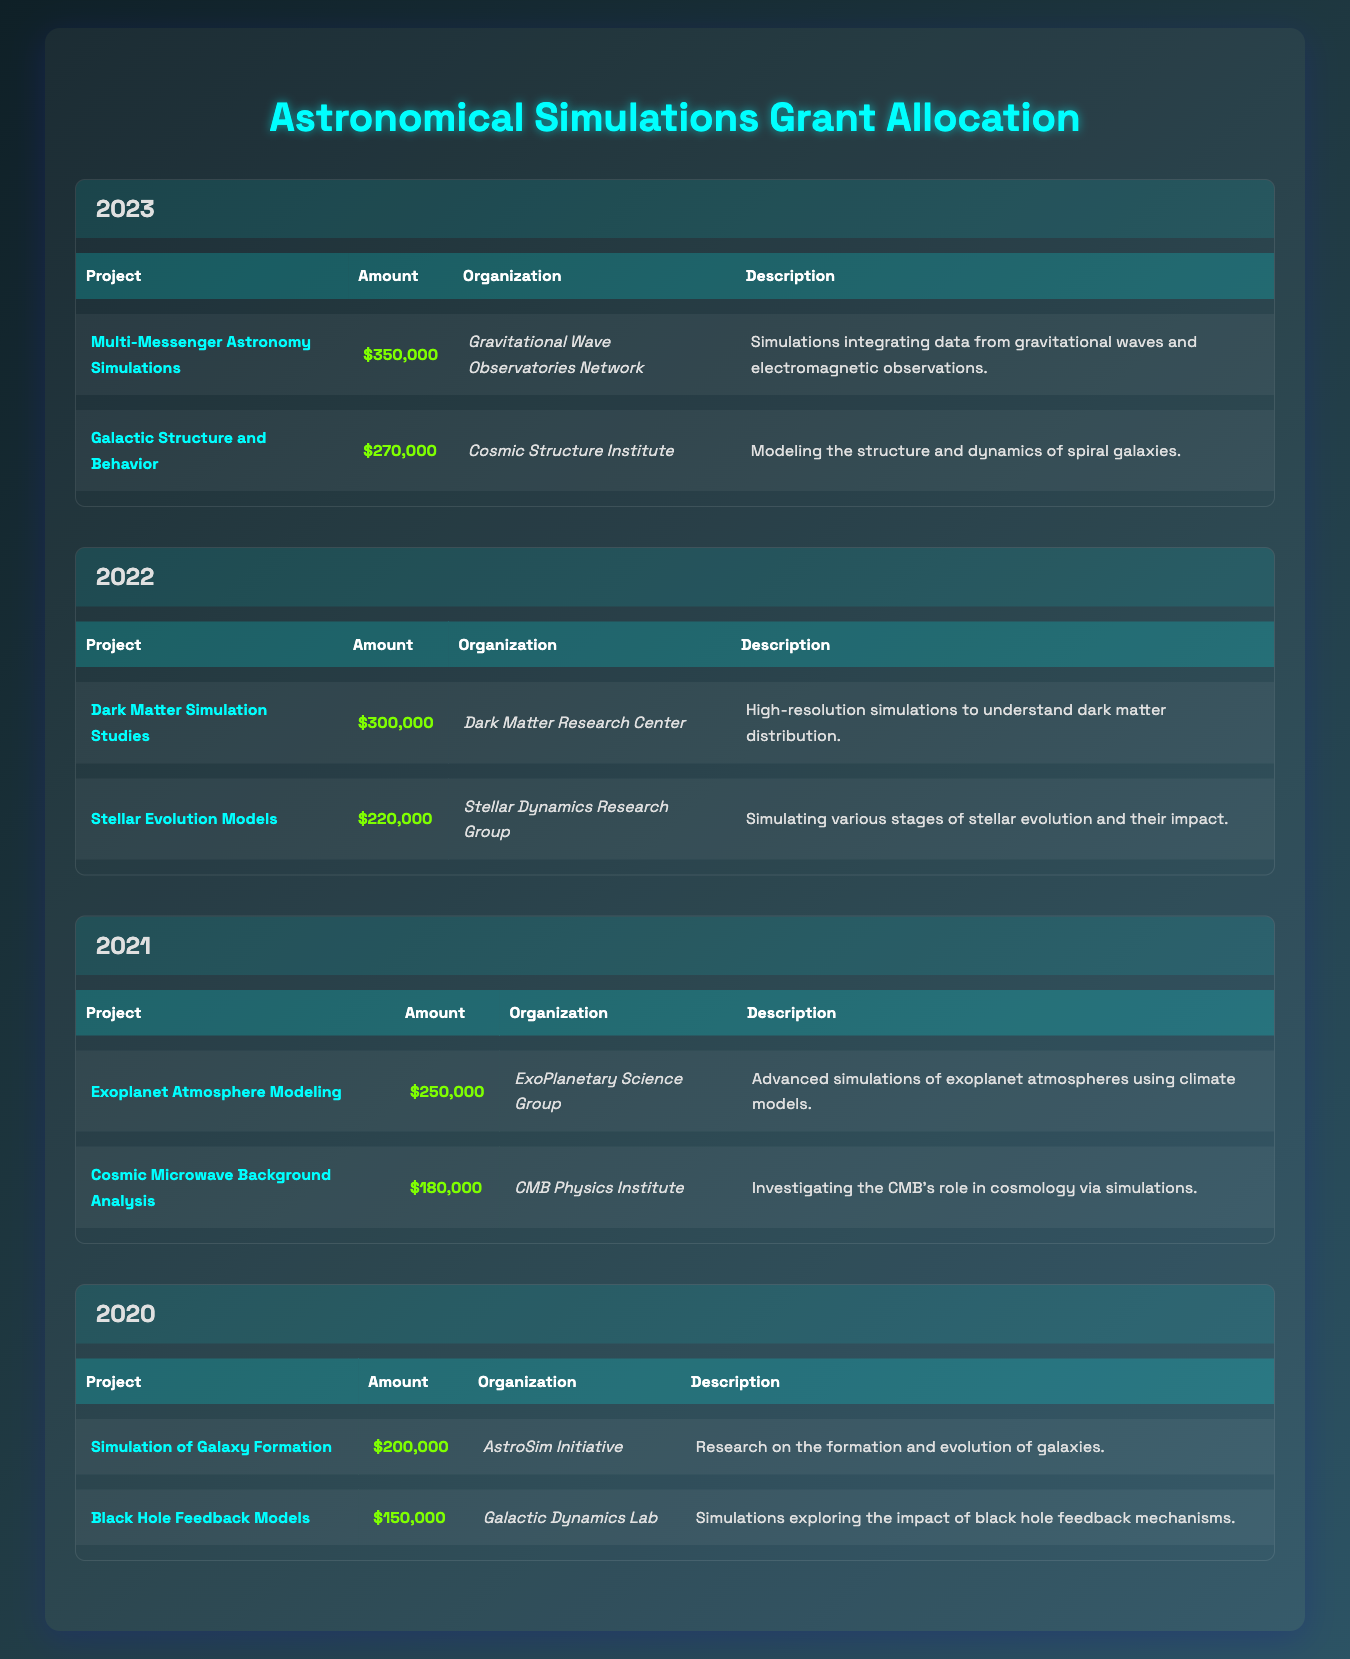What is the total grant amount allocated in 2022? In 2022, there are two projects listed with their amounts: Dark Matter Simulation Studies ($300,000) and Stellar Evolution Models ($220,000). Adding these amounts gives us $300,000 + $220,000 = $520,000.
Answer: $520,000 Which organization received the highest grant in 2023? In 2023, there are two projects: Multi-Messenger Astronomy Simulations ($350,000) and Galactic Structure and Behavior ($270,000). The organization that received the highest grant is for Multi-Messenger Astronomy Simulations, which is the Gravitational Wave Observatories Network.
Answer: Gravitational Wave Observatories Network Did the grant amount for Exoplanet Atmosphere Modeling exceed $200,000? The amount allocated for Exoplanet Atmosphere Modeling in 2021 is $250,000. Since $250,000 is greater than $200,000, the statement is true.
Answer: Yes What is the combined grant amount for all projects in 2021? In 2021, there are two projects with amounts: Exoplanet Atmosphere Modeling ($250,000) and Cosmic Microwave Background Analysis ($180,000). The combined grant amount is calculated as $250,000 + $180,000 = $430,000.
Answer: $430,000 Is there any project related to black holes in the data? The data includes a project titled Black Hole Feedback Models in 2020, which distinctly identifies its focus on black hole mechanisms. Therefore, the answer is yes, there is a project about black holes.
Answer: Yes What was the total grant amount allocated across all years from 2020 to 2023? The total amounts by year are: 2020 ($200,000 + $150,000 = $350,000), 2021 ($250,000 + $180,000 = $430,000), 2022 ($300,000 + $220,000 = $520,000), and 2023 ($350,000 + $270,000 = $620,000). Adding these totals gives $350,000 + $430,000 + $520,000 + $620,000 = $1,920,000.
Answer: $1,920,000 Which project in 2022 had the lowest grant amount? In 2022, the two projects and their amounts are Dark Matter Simulation Studies ($300,000) and Stellar Evolution Models ($220,000). The project with the lowest amount is the Stellar Evolution Models at $220,000.
Answer: Stellar Evolution Models How much more funding was allocated to projects in 2023 compared to those in 2021? In 2023, the total funding is $350,000 + $270,000 = $620,000 and in 2021, it is $430,000. The difference is $620,000 - $430,000 = $190,000, indicating that 2023 had $190,000 more in allocated funds.
Answer: $190,000 